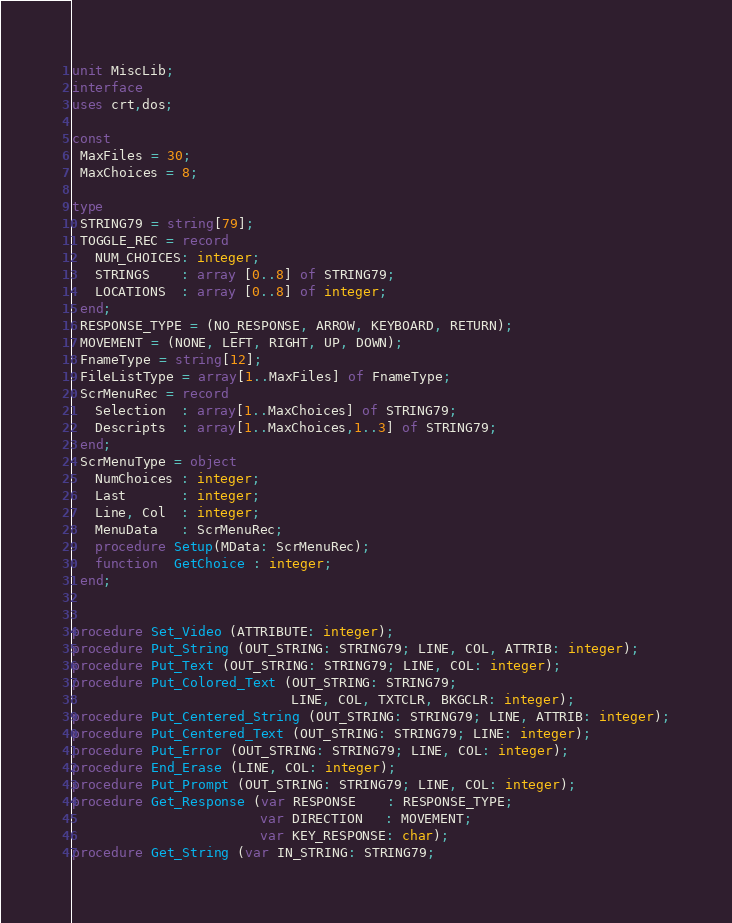Convert code to text. <code><loc_0><loc_0><loc_500><loc_500><_Pascal_>unit MiscLib;
interface
uses crt,dos;

const
 MaxFiles = 30;
 MaxChoices = 8;

type
 STRING79 = string[79];
 TOGGLE_REC = record
   NUM_CHOICES: integer;
   STRINGS    : array [0..8] of STRING79;
   LOCATIONS  : array [0..8] of integer;
 end;
 RESPONSE_TYPE = (NO_RESPONSE, ARROW, KEYBOARD, RETURN);
 MOVEMENT = (NONE, LEFT, RIGHT, UP, DOWN);
 FnameType = string[12];
 FileListType = array[1..MaxFiles] of FnameType;
 ScrMenuRec = record
   Selection  : array[1..MaxChoices] of STRING79;
   Descripts  : array[1..MaxChoices,1..3] of STRING79;
 end;
 ScrMenuType = object
   NumChoices : integer;
   Last       : integer;
   Line, Col  : integer;
   MenuData   : ScrMenuRec;
   procedure Setup(MData: ScrMenuRec);
   function  GetChoice : integer;
 end;


procedure Set_Video (ATTRIBUTE: integer);
procedure Put_String (OUT_STRING: STRING79; LINE, COL, ATTRIB: integer);
procedure Put_Text (OUT_STRING: STRING79; LINE, COL: integer);
procedure Put_Colored_Text (OUT_STRING: STRING79;
                            LINE, COL, TXTCLR, BKGCLR: integer);
procedure Put_Centered_String (OUT_STRING: STRING79; LINE, ATTRIB: integer);
procedure Put_Centered_Text (OUT_STRING: STRING79; LINE: integer);
procedure Put_Error (OUT_STRING: STRING79; LINE, COL: integer);
procedure End_Erase (LINE, COL: integer);
procedure Put_Prompt (OUT_STRING: STRING79; LINE, COL: integer);
procedure Get_Response (var RESPONSE    : RESPONSE_TYPE;
                        var DIRECTION   : MOVEMENT;
                        var KEY_RESPONSE: char);
procedure Get_String (var IN_STRING: STRING79;</code> 